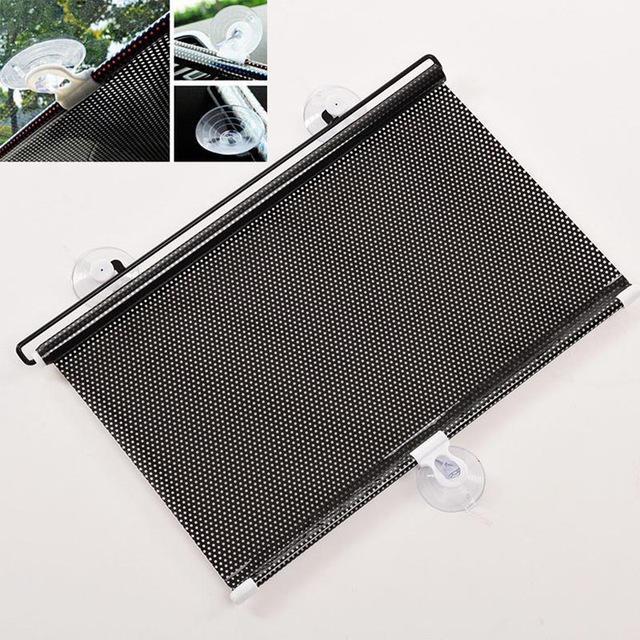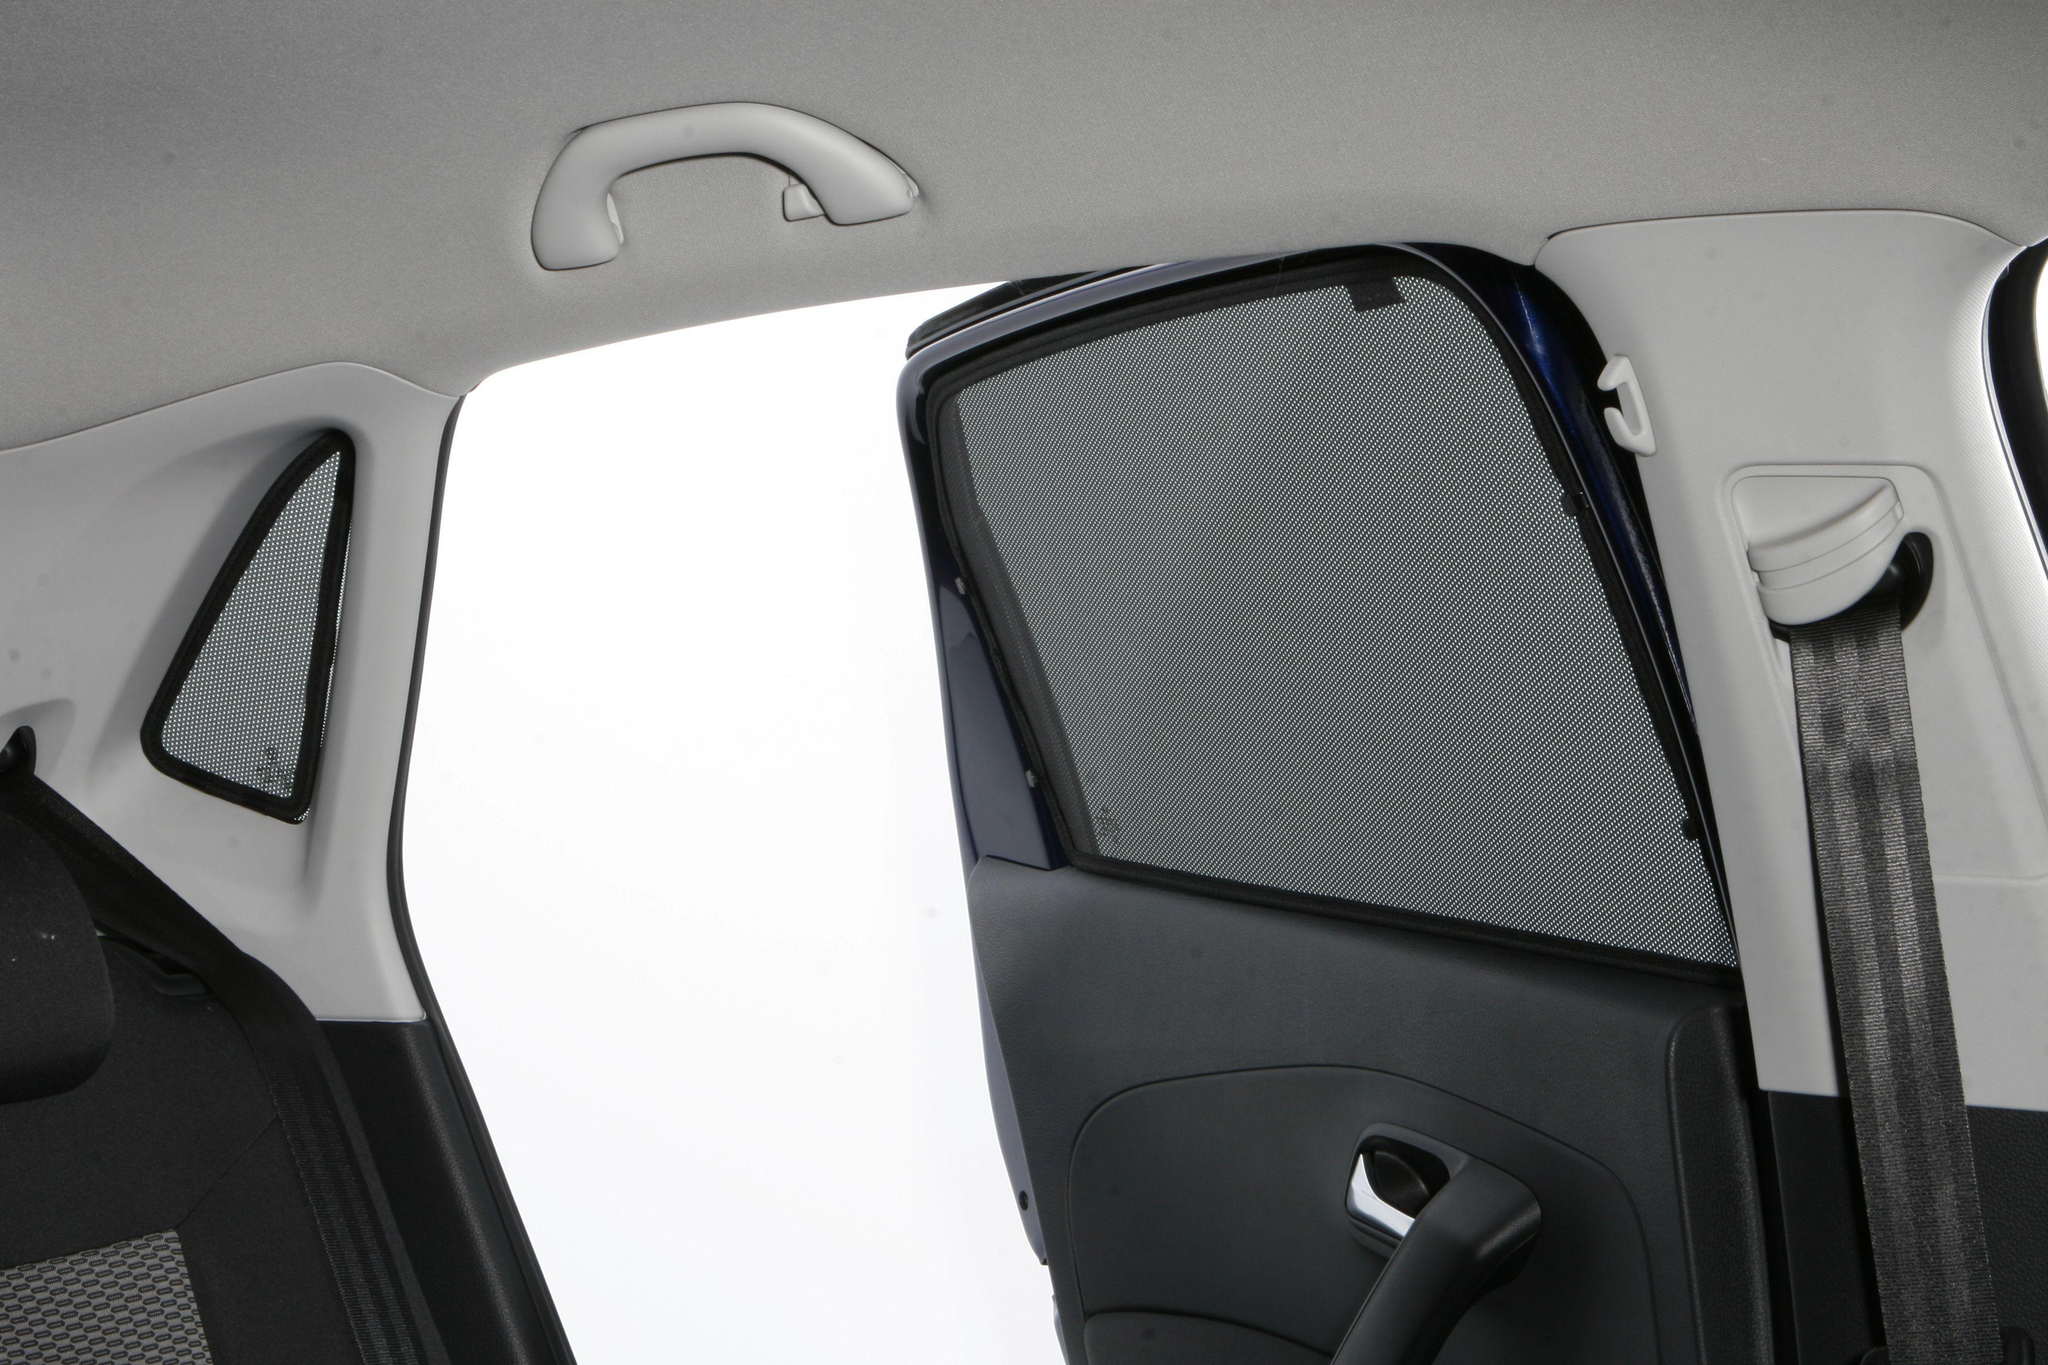The first image is the image on the left, the second image is the image on the right. Considering the images on both sides, is "The right image shows the vehicle's interior with a shaded window." valid? Answer yes or no. Yes. 